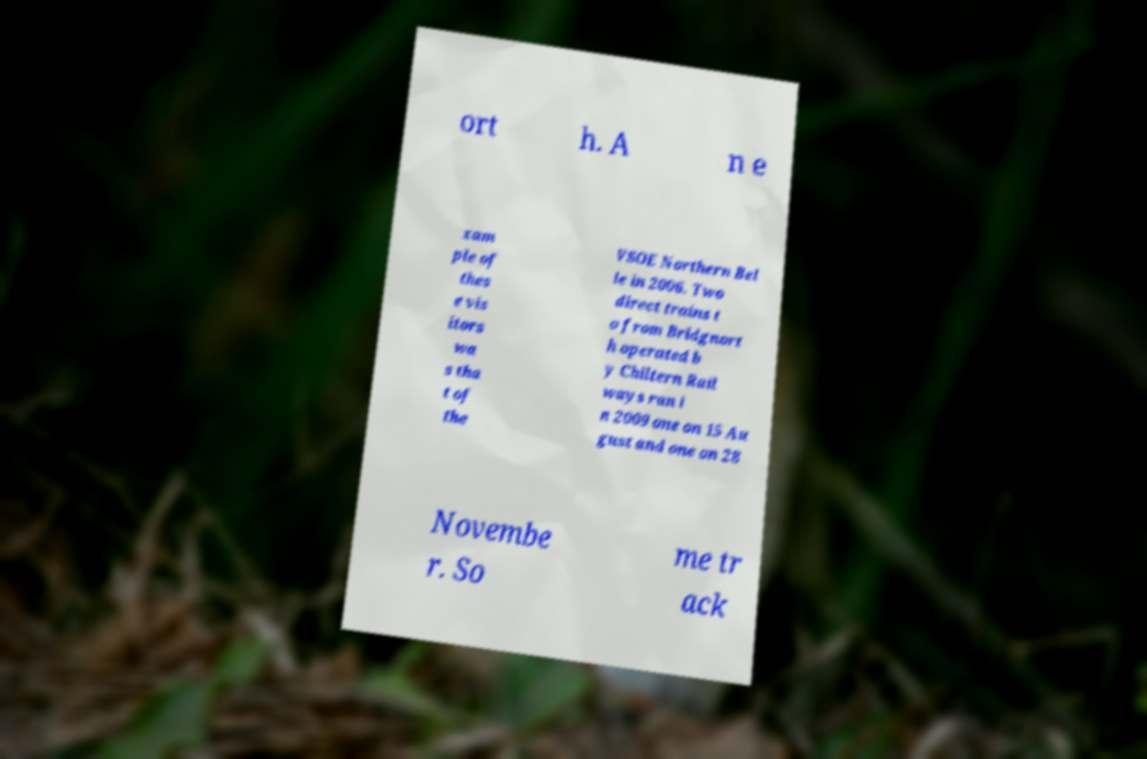Could you extract and type out the text from this image? ort h. A n e xam ple of thes e vis itors wa s tha t of the VSOE Northern Bel le in 2006. Two direct trains t o from Bridgnort h operated b y Chiltern Rail ways ran i n 2009 one on 15 Au gust and one on 28 Novembe r. So me tr ack 